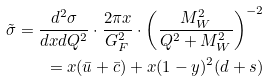Convert formula to latex. <formula><loc_0><loc_0><loc_500><loc_500>\tilde { \sigma } = \frac { d ^ { 2 } \sigma } { d x d Q ^ { 2 } } \cdot \frac { 2 \pi x } { G _ { F } ^ { 2 } } \cdot \left ( \frac { M _ { W } ^ { 2 } } { Q ^ { 2 } + M _ { W } ^ { 2 } } \right ) ^ { - 2 } \\ = x ( \bar { u } + \bar { c } ) + x ( 1 - y ) ^ { 2 } ( d + s )</formula> 